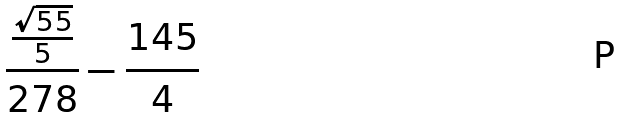Convert formula to latex. <formula><loc_0><loc_0><loc_500><loc_500>\frac { \frac { \sqrt { 5 5 } } { 5 } } { 2 7 8 } - \frac { 1 4 5 } { 4 }</formula> 